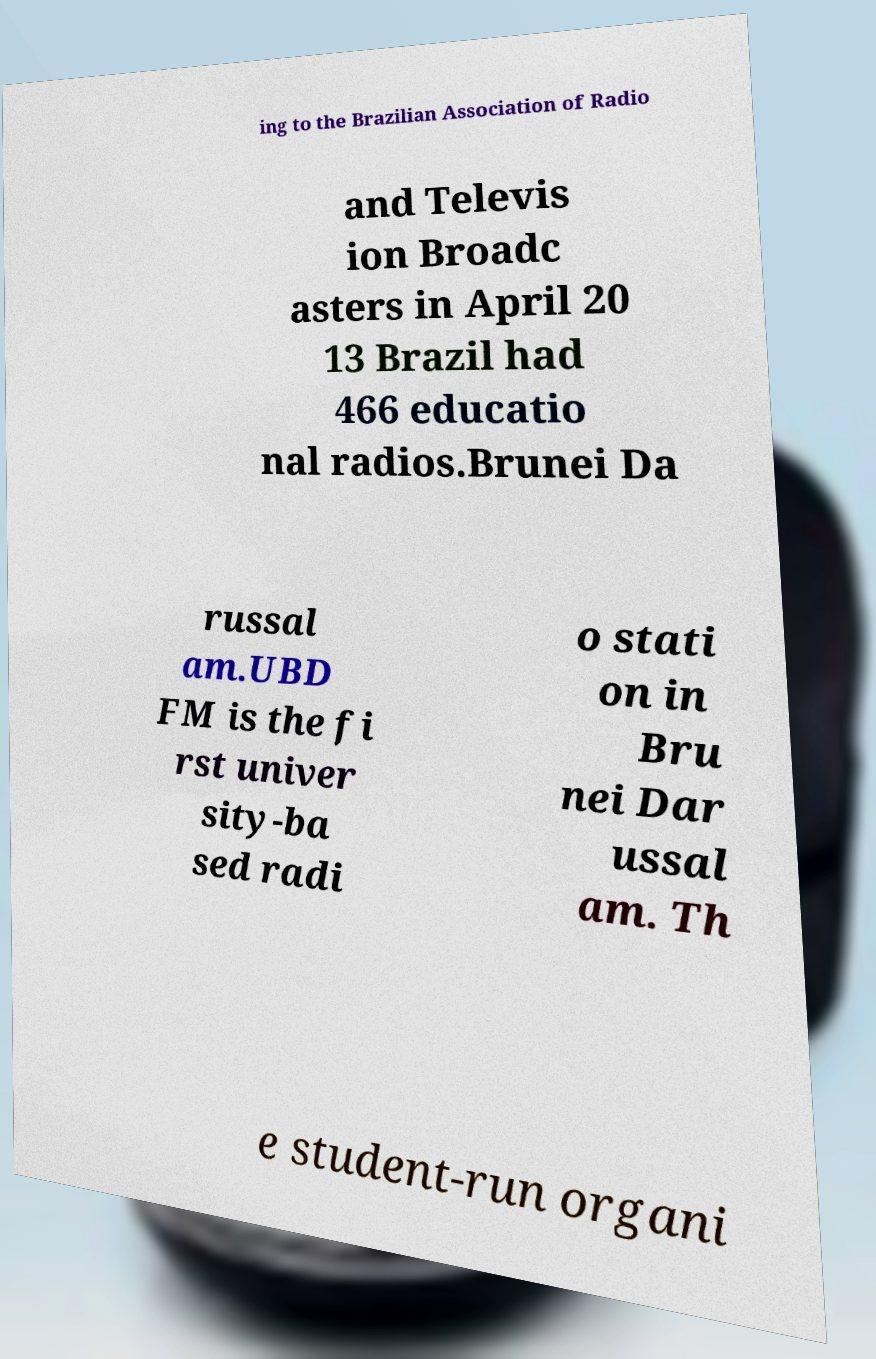Can you read and provide the text displayed in the image?This photo seems to have some interesting text. Can you extract and type it out for me? ing to the Brazilian Association of Radio and Televis ion Broadc asters in April 20 13 Brazil had 466 educatio nal radios.Brunei Da russal am.UBD FM is the fi rst univer sity-ba sed radi o stati on in Bru nei Dar ussal am. Th e student-run organi 